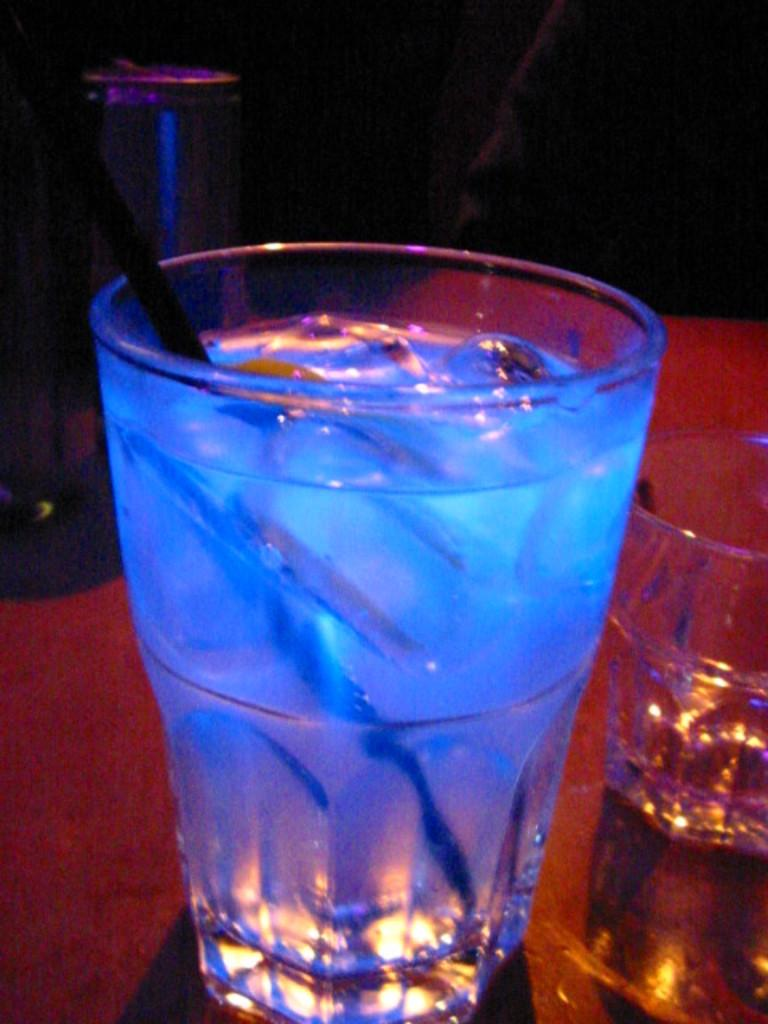What is in the glass that is visible in the image? There is a glass with liquid in the image, and it contains ice cubes. What is used to stir the liquid in the glass? There is a spoon in the glass. Where is the glass placed in the image? The glass is on a platform. How many glasses can be seen in the image? There are two glasses in the image. Can you describe the person in the image? There is a person in the image, but no specific details about their appearance or actions are provided. What other objects are present in the image? There are other objects in the image, but no specific details about them are provided. Can you tell me how many rabbits are in the bath in the image? There are no rabbits or baths present in the image. What type of stick is being used by the person in the image? There is no stick visible in the image, and no specific details about the person's actions are provided. 